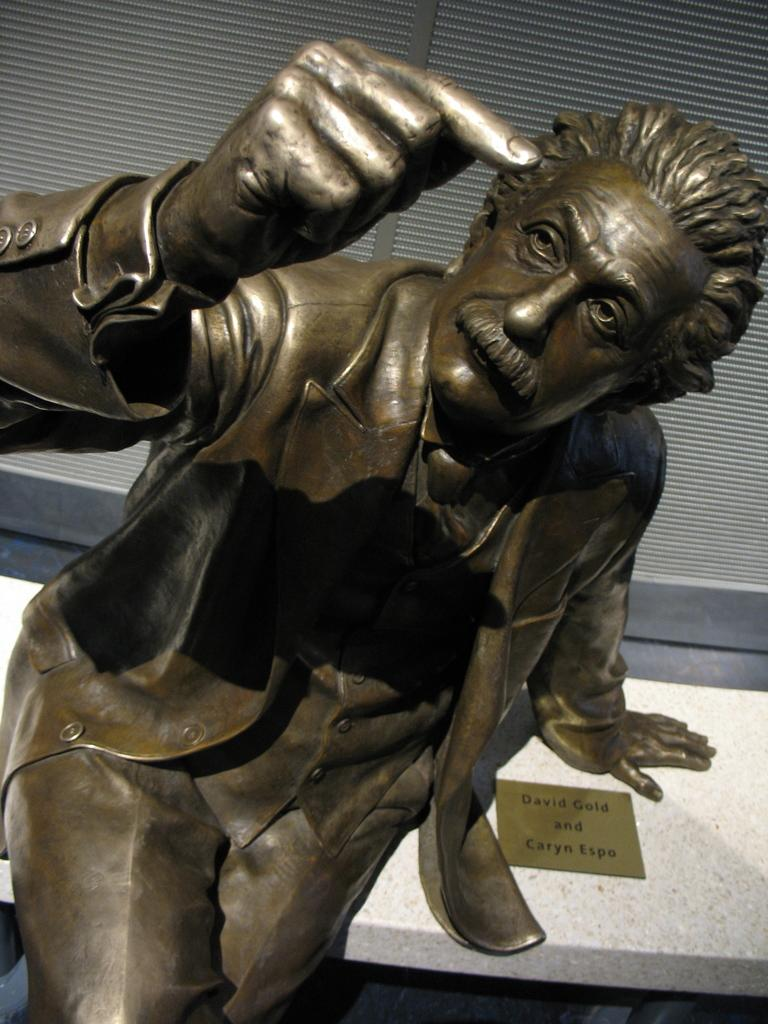What is the main subject of the image? There is a statue of a man in the image. What is the man wearing in the image? The man is wearing a coat in the image. What additional object can be seen in the image? There is a name board in the image. What can be seen in the background of the image? There is a curtain in the background of the image. How many cats are sitting on the man's lap in the image? There are no cats present in the image; it features a statue of a man wearing a coat. What type of pocket is visible on the man's coat in the image? There is no pocket visible on the man's coat in the image, as it is a statue and not a real person. 